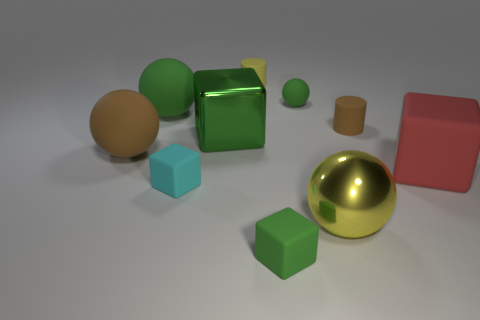Subtract all big green spheres. How many spheres are left? 3 Subtract 1 cylinders. How many cylinders are left? 1 Subtract all cylinders. How many objects are left? 8 Add 5 green metallic cubes. How many green metallic cubes exist? 6 Subtract all yellow cylinders. How many cylinders are left? 1 Subtract 1 brown balls. How many objects are left? 9 Subtract all cyan spheres. Subtract all gray cubes. How many spheres are left? 4 Subtract all yellow cylinders. How many green balls are left? 2 Subtract all cyan objects. Subtract all small brown objects. How many objects are left? 8 Add 1 big yellow things. How many big yellow things are left? 2 